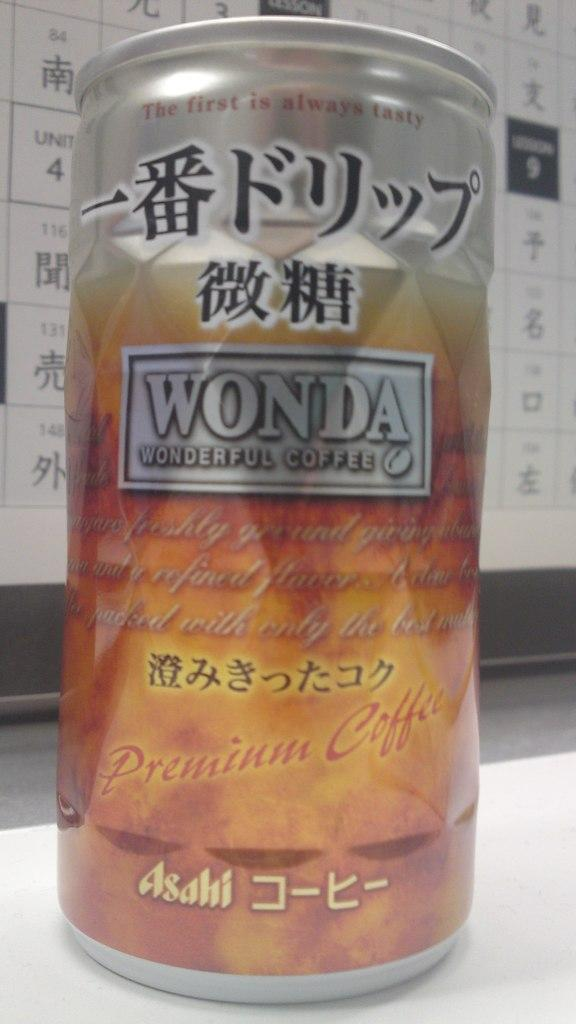Provide a one-sentence caption for the provided image. A can of Wonda coffee with kanji writing. 